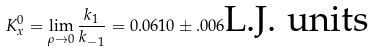Convert formula to latex. <formula><loc_0><loc_0><loc_500><loc_500>K _ { x } ^ { 0 } = \lim _ { \rho \rightarrow 0 } \frac { k _ { 1 } } { k _ { - 1 } } = 0 . 0 6 1 0 \pm . 0 0 6 \text {L.J. units}</formula> 